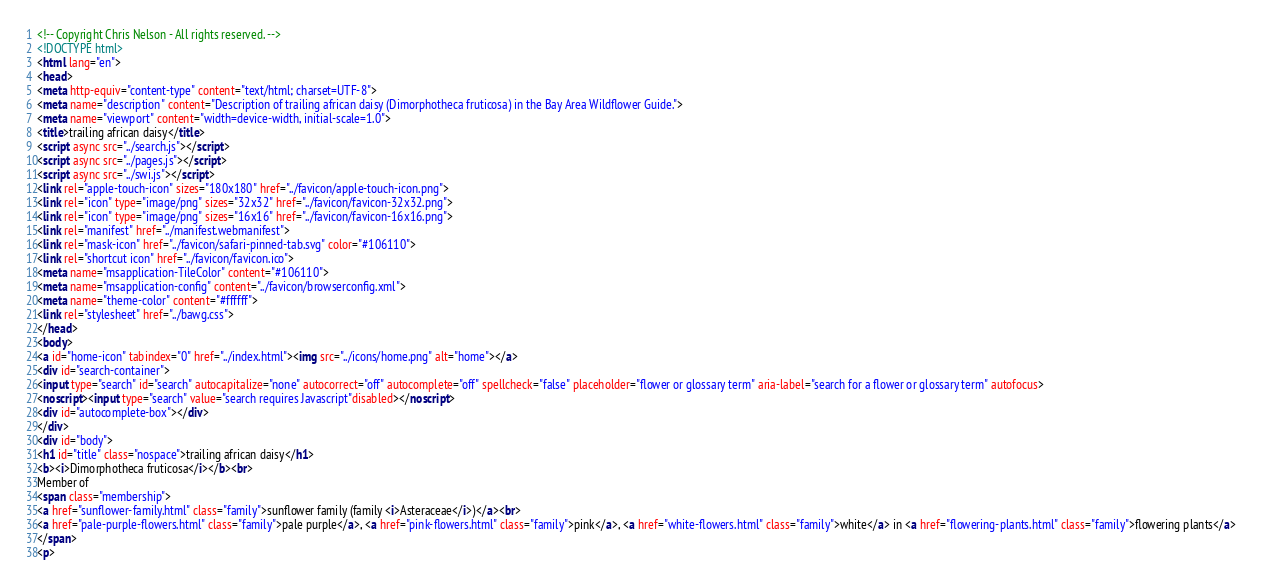<code> <loc_0><loc_0><loc_500><loc_500><_HTML_><!-- Copyright Chris Nelson - All rights reserved. -->
<!DOCTYPE html>
<html lang="en">
<head>
<meta http-equiv="content-type" content="text/html; charset=UTF-8">
<meta name="description" content="Description of trailing african daisy (Dimorphotheca fruticosa) in the Bay Area Wildflower Guide.">
<meta name="viewport" content="width=device-width, initial-scale=1.0">
<title>trailing african daisy</title>
<script async src="../search.js"></script>
<script async src="../pages.js"></script>
<script async src="../swi.js"></script>
<link rel="apple-touch-icon" sizes="180x180" href="../favicon/apple-touch-icon.png">
<link rel="icon" type="image/png" sizes="32x32" href="../favicon/favicon-32x32.png">
<link rel="icon" type="image/png" sizes="16x16" href="../favicon/favicon-16x16.png">
<link rel="manifest" href="../manifest.webmanifest">
<link rel="mask-icon" href="../favicon/safari-pinned-tab.svg" color="#106110">
<link rel="shortcut icon" href="../favicon/favicon.ico">
<meta name="msapplication-TileColor" content="#106110">
<meta name="msapplication-config" content="../favicon/browserconfig.xml">
<meta name="theme-color" content="#ffffff">
<link rel="stylesheet" href="../bawg.css">
</head>
<body>
<a id="home-icon" tabindex="0" href="../index.html"><img src="../icons/home.png" alt="home"></a>
<div id="search-container">
<input type="search" id="search" autocapitalize="none" autocorrect="off" autocomplete="off" spellcheck="false" placeholder="flower or glossary term" aria-label="search for a flower or glossary term" autofocus>
<noscript><input type="search" value="search requires Javascript"disabled></noscript>
<div id="autocomplete-box"></div>
</div>
<div id="body">
<h1 id="title" class="nospace">trailing african daisy</h1>
<b><i>Dimorphotheca fruticosa</i></b><br>
Member of
<span class="membership">
<a href="sunflower-family.html" class="family">sunflower family (family <i>Asteraceae</i>)</a><br>
<a href="pale-purple-flowers.html" class="family">pale purple</a>, <a href="pink-flowers.html" class="family">pink</a>, <a href="white-flowers.html" class="family">white</a> in <a href="flowering-plants.html" class="family">flowering plants</a>
</span>
<p></code> 